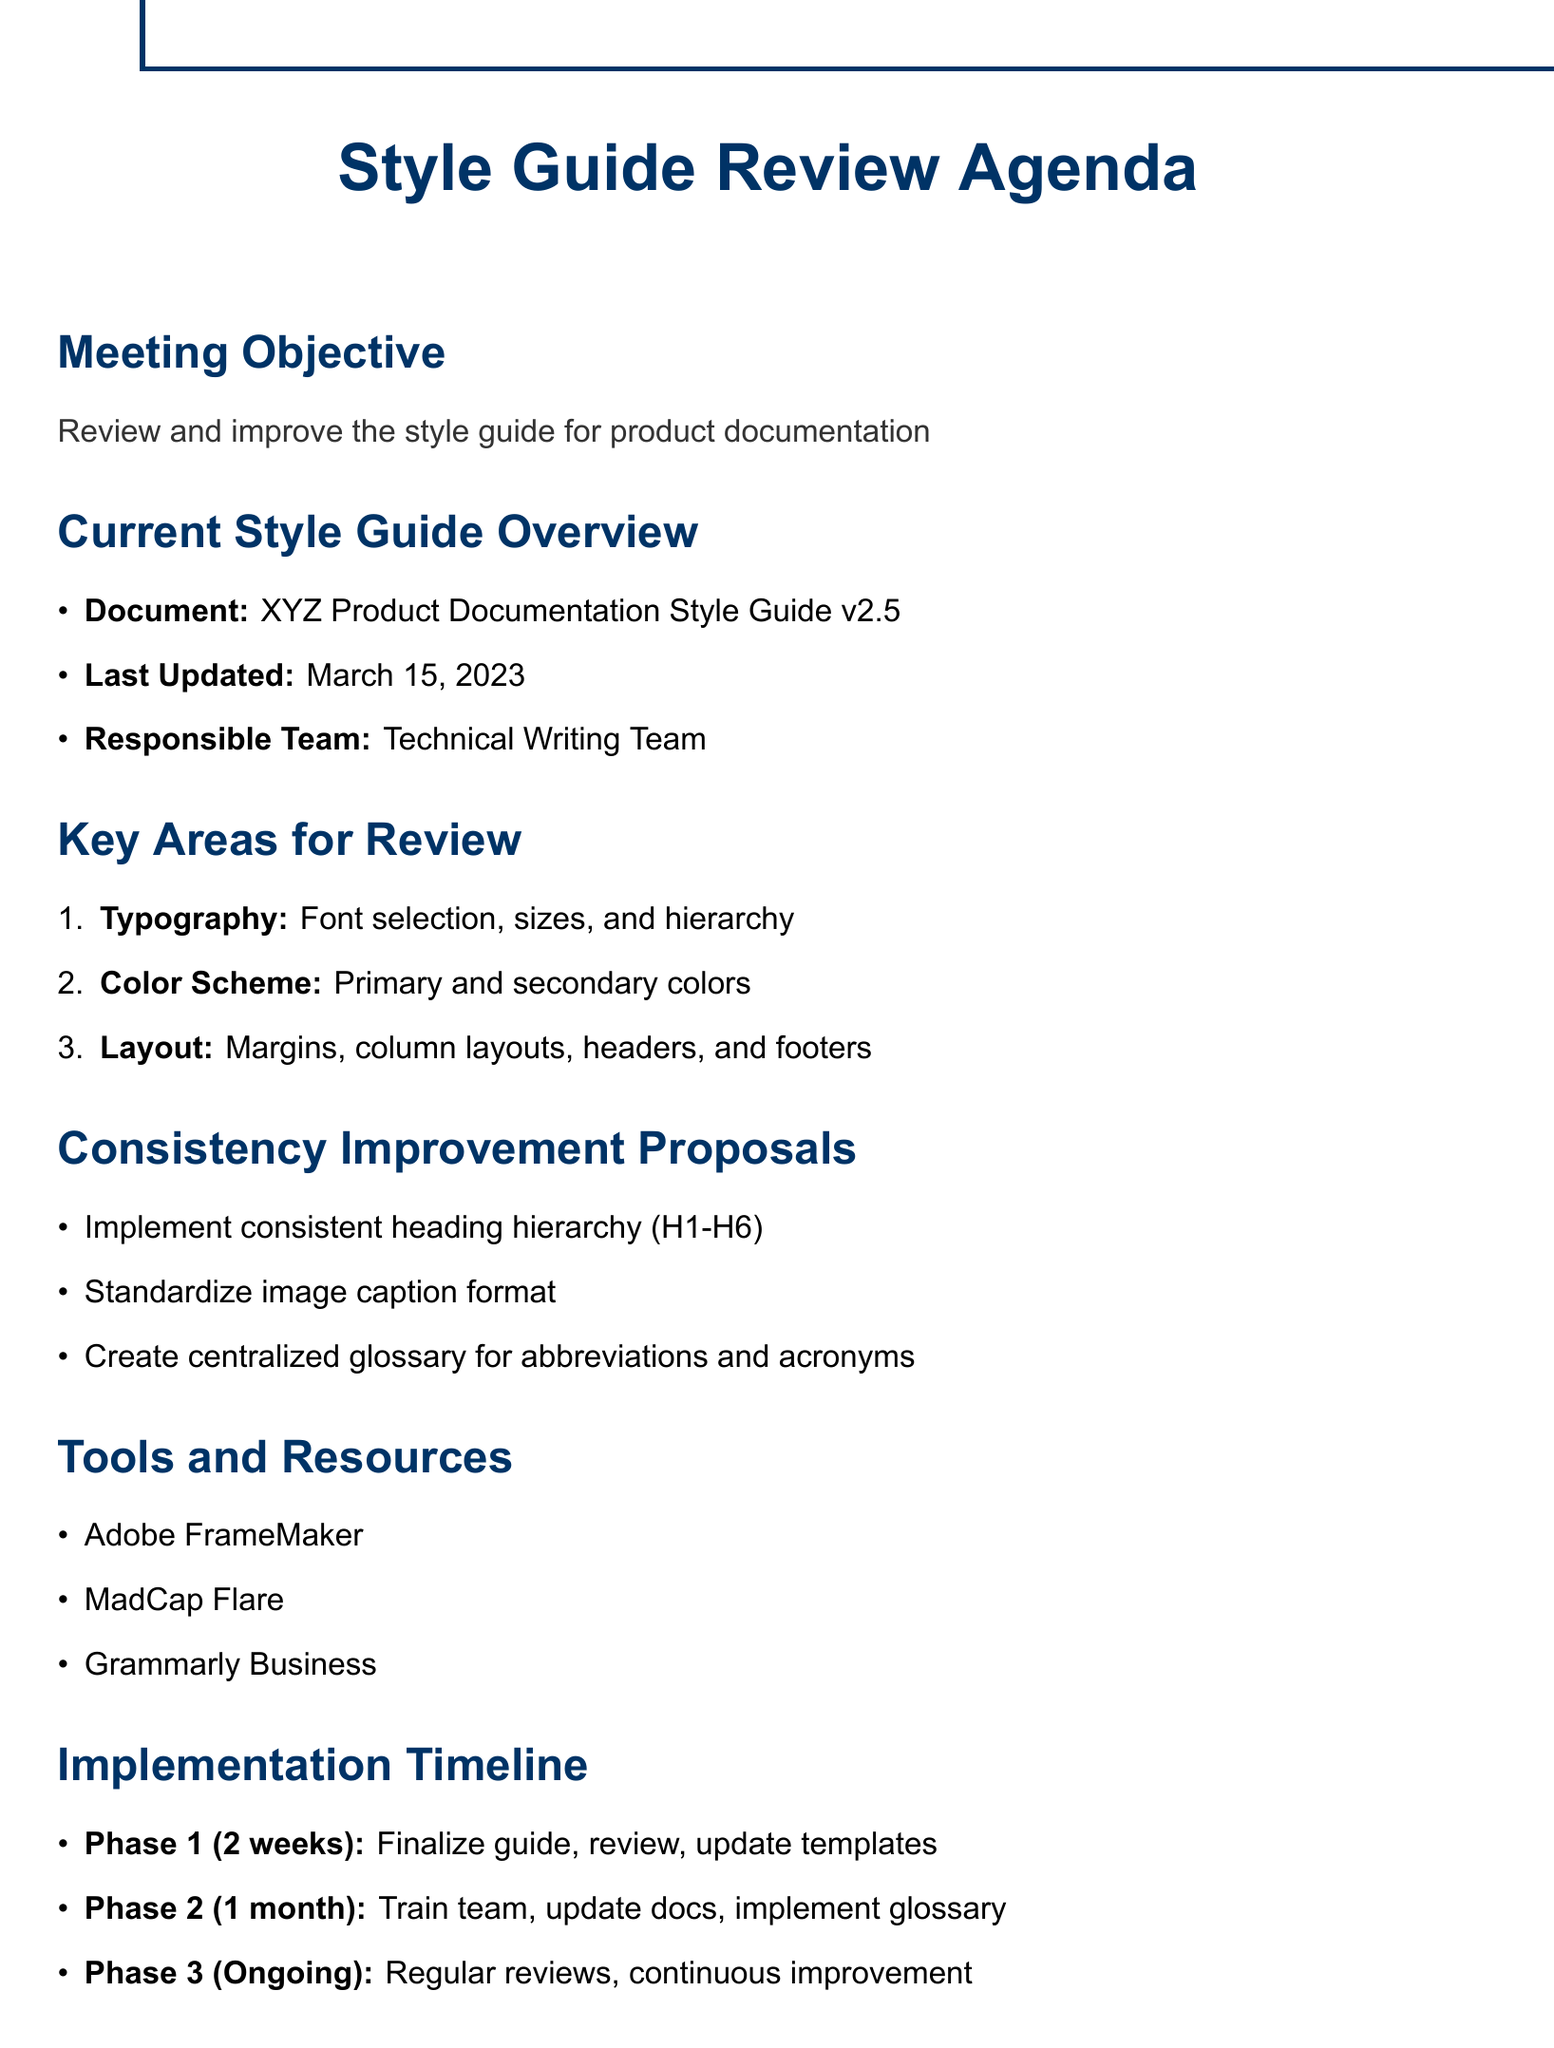What is the document name? The document name is stated in the Current Style Guide Overview section.
Answer: XYZ Product Documentation Style Guide v2.5 When was the last update made to the style guide? The last updated date is found in the Current Style Guide Overview section.
Answer: March 15, 2023 Who is responsible for the style guide? The responsible team for the style guide is mentioned in the Current Style Guide Overview section.
Answer: Technical Writing Team What is the duration of Phase 1 of the implementation timeline? The duration for Phase 1 is specified in the Implementation Timeline section.
Answer: 2 weeks What is the first proposal for consistency improvement? The first proposal can be found under the Consistency Improvement Proposals section.
Answer: Implement a consistent heading hierarchy across all product lines using H1-H6 tags with predefined styles Who is responsible for the final approval of style guide changes? The individual responsible for final approval is mentioned in the Key Stakeholders section.
Answer: Sarah Johnson What tool is specified as the primary authoring tool? The primary authoring tool is listed in the Tools and Resources section.
Answer: Adobe FrameMaker What task is included in Phase 2 of the implementation? Phase 2 tasks can be found in the Implementation Timeline section.
Answer: Train writing team on new standards 